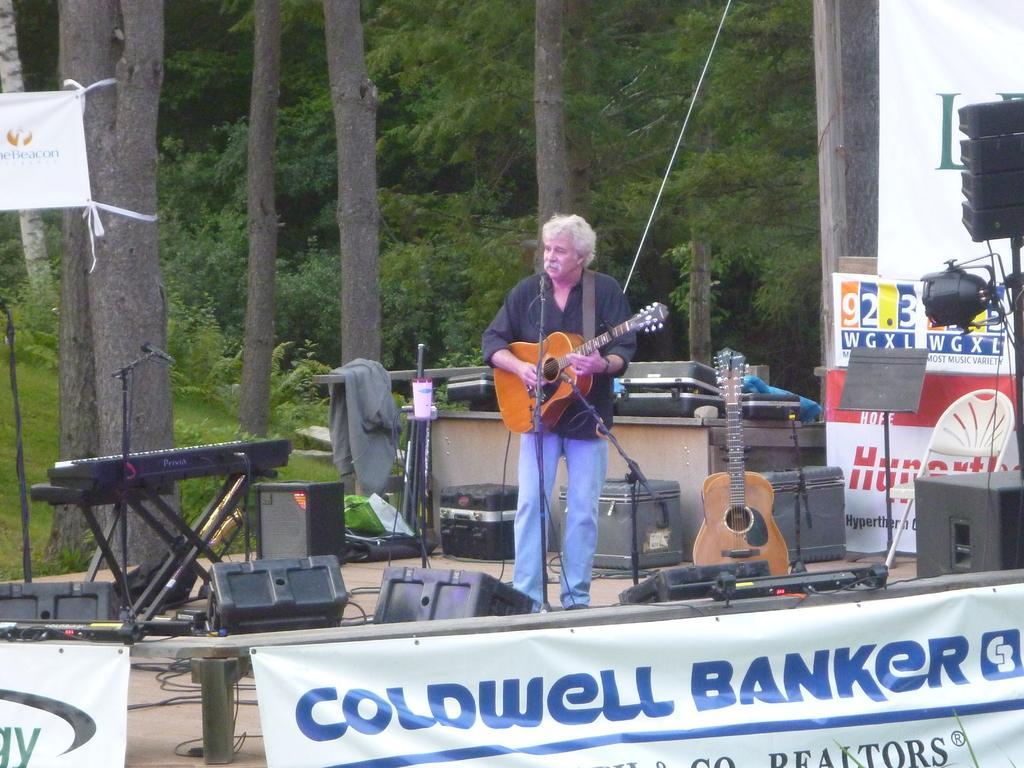How would you summarize this image in a sentence or two? In this image there is a man standing and playing a guitar and at the back ground there is a banner ,speaker,light,tree,jacket , another guitar , piano. 